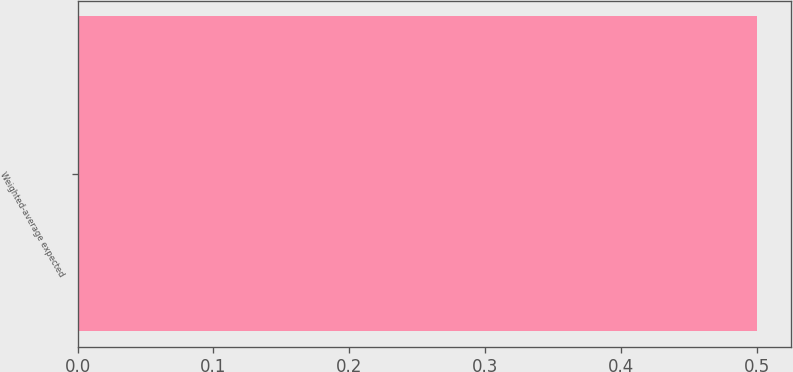Convert chart. <chart><loc_0><loc_0><loc_500><loc_500><bar_chart><fcel>Weighted-average expected<nl><fcel>0.5<nl></chart> 